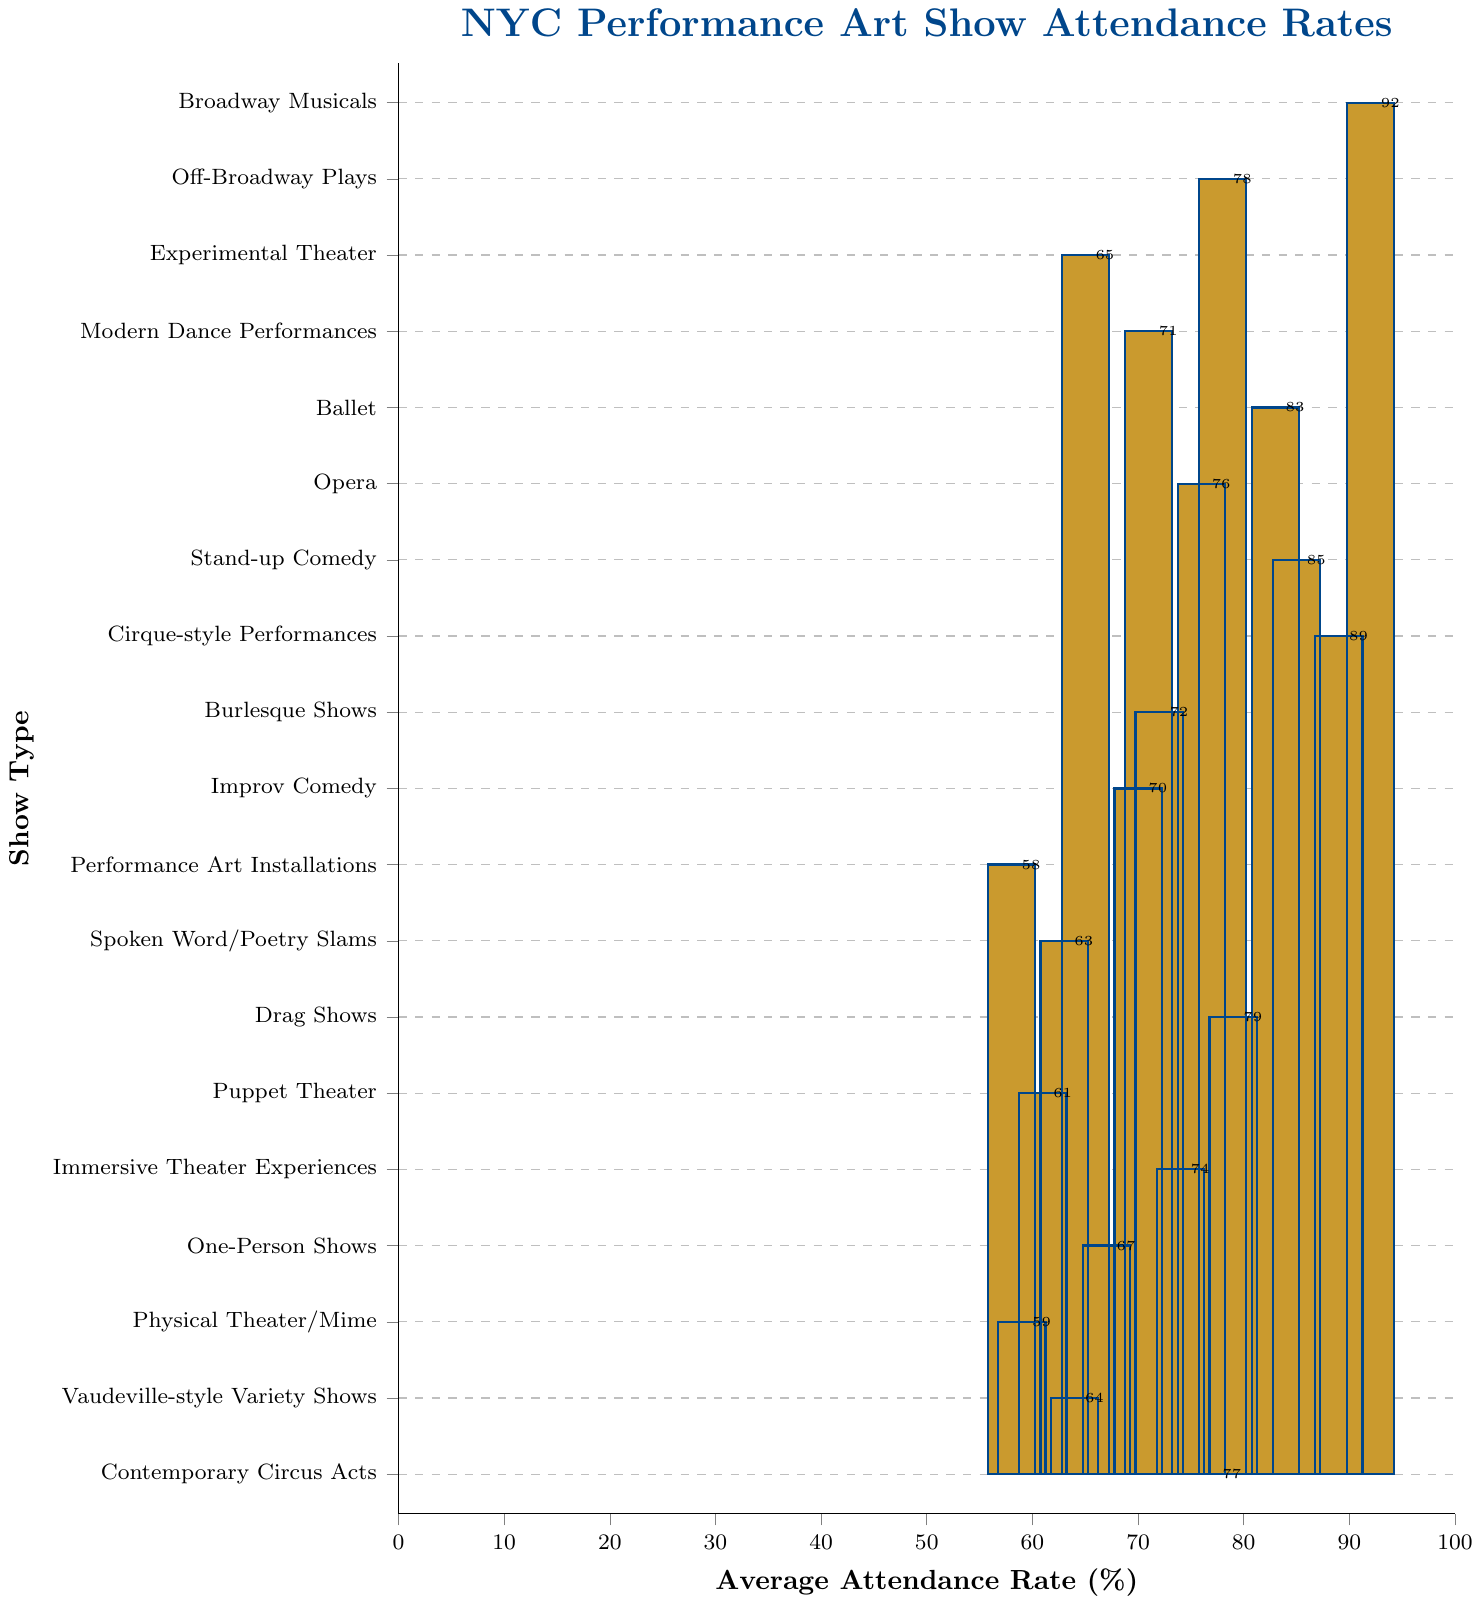What's the highest average attendance rate among the different types of performance art shows? The highest average attendance rate is indicated by the tallest bar in the chart. In this case, it corresponds to Broadway Musicals with an attendance rate of 92%.
Answer: 92% Which show type has the lowest attendance rate? The lowest attendance rate corresponds to the shortest bar in the chart. Performance Art Installations have the lowest rate at 58%.
Answer: 58% Are ballet and opera attendance rates higher or lower than 80%? By examining the bars for ballet and opera, it is evident that ballet has an attendance rate of 83% (higher than 80%) and opera has an attendance rate of 76% (lower than 80%).
Answer: Ballet: Higher, Opera: Lower What is the combined attendance rate percentage of Stand-up Comedy and Cirque-style Performances? The attendance rate for Stand-up Comedy is 85% and for Cirque-style Performances is 89%. Adding these together: 85 + 89 = 174%.
Answer: 174% Which show type has nearly the same attendance rate as Cabaret Shows? Looking at the bars, Drag Shows have an attendance rate close to Cabaret Shows. Cabaret Shows have 68% and Drag Shows have 79%. Both rates are relatively similar.
Answer: Drag Shows What is the difference in average attendance rate between Broadway Musicals and Experimental Theater? The attendance rate for Broadway Musicals is 92% and for Experimental Theater is 65%. Subtracting these: 92 - 65 = 27%.
Answer: 27% Which two performance arts have attendance rates closest to each other and what are their rates? By comparing the bars, Spoken Word/Poetry Slams and Experimental Theater have quite close rates, 63% and 65% respectively.
Answer: Spoken Word/Poetry Slams: 63%, Experimental Theater: 65% How many performance art show types have an attendance rate above 70%? Count the number of bars that exceed the 70% mark. There are 10 show types: Broadway Musicals, Off-Broadway Plays, Ballet, Stand-up Comedy, Cirque-style Performances, Drag Shows, Contemporary Circus Acts, Opera, Modern Dance Performances, Burlesque Shows.
Answer: 10 What's the average attendance rate for all performance art types shown on the chart? Sum all attendance rates and divide by the number of show types: (92 + 78 + 65 + 71 + 83 + 76 + 68 + 85 + 89 + 72 + 70 + 58 + 63 + 79 + 61 + 74 + 67 + 59 + 64 + 77) / 20 = 71.5%.
Answer: 71.5% Which show types have an attendance rate between 60% and 70%? Show types within the 60% to 70% bracket by examining the bars: Experimental Theater (65%), Improv Comedy (70%), Burlesque Shows (72%), Spoken Word/Poetry Slams (63%), Puppet Theater (61%), One-Person Shows (67%), Physical Theater/Mime (59%), and Vaudeville-style Variety Shows (64%).
Answer: Experimental Theater, Improv Comedy, Burlesque Shows, Spoken Word/Poetry Slams, Puppet Theater, One-Person Shows, Physical Theater/Mime, Vaudeville-style Variety Shows 